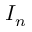<formula> <loc_0><loc_0><loc_500><loc_500>I _ { n }</formula> 